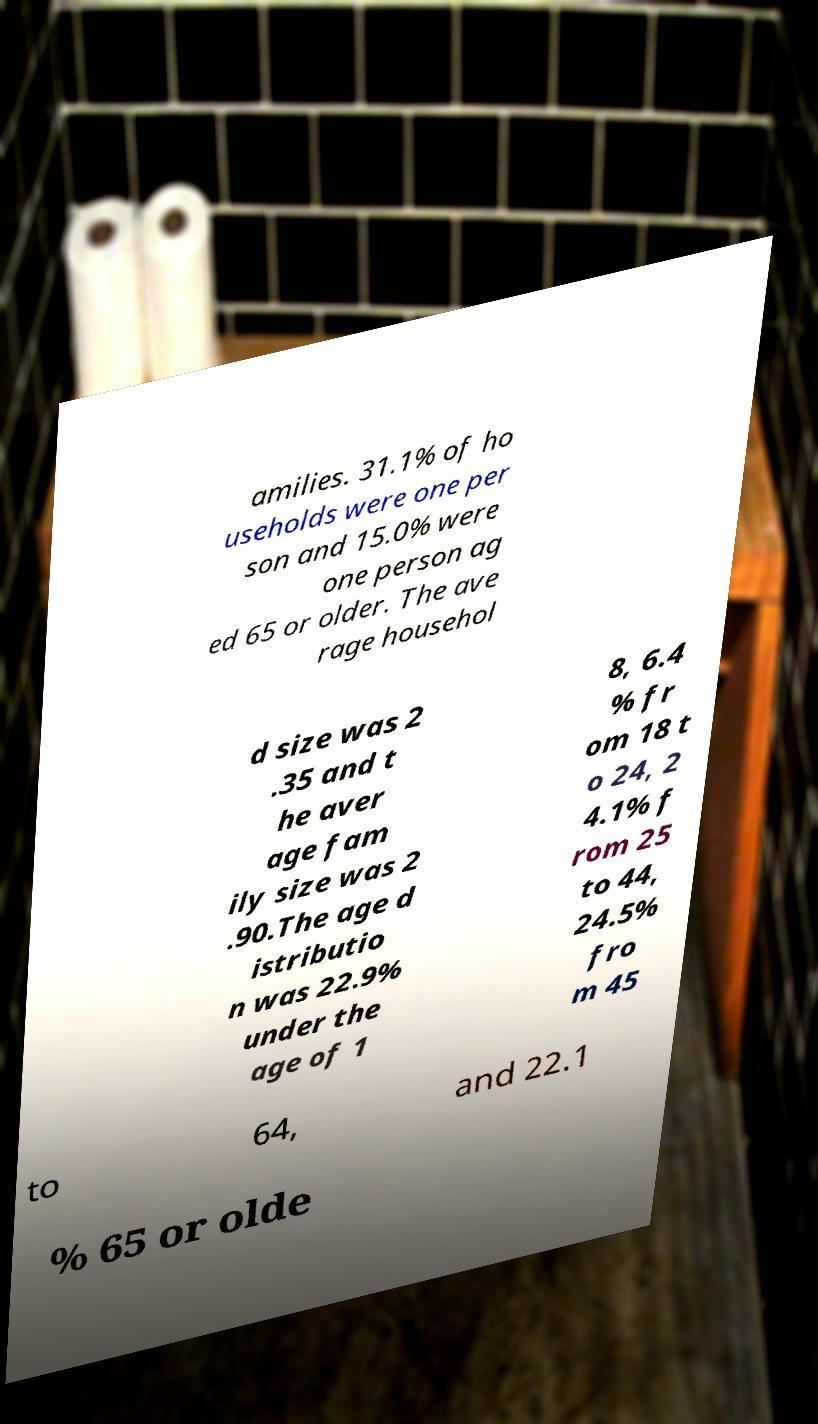Please read and relay the text visible in this image. What does it say? amilies. 31.1% of ho useholds were one per son and 15.0% were one person ag ed 65 or older. The ave rage househol d size was 2 .35 and t he aver age fam ily size was 2 .90.The age d istributio n was 22.9% under the age of 1 8, 6.4 % fr om 18 t o 24, 2 4.1% f rom 25 to 44, 24.5% fro m 45 to 64, and 22.1 % 65 or olde 